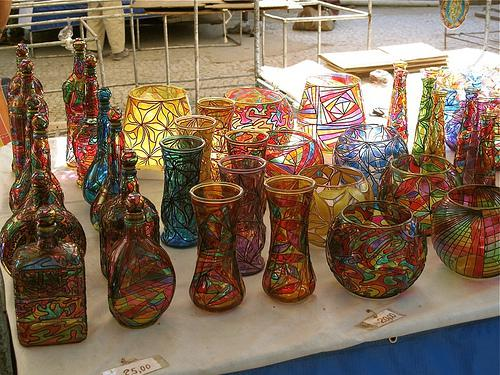Question: what are on display?
Choices:
A. Flowers.
B. Cars.
C. Dresses.
D. Vases.
Answer with the letter. Answer: D Question: what are the vases made of?
Choices:
A. Glass.
B. Porcelin.
C. Plastic.
D. Aluminum.
Answer with the letter. Answer: A Question: why are the vases on display?
Choices:
A. To show the flowers.
B. They are free.
C. For mother's day.
D. They are for sale.
Answer with the letter. Answer: D Question: where are the vases?
Choices:
A. On the table.
B. In the store.
C. On the counter.
D. On the mantel.
Answer with the letter. Answer: A Question: who is in the photo?
Choices:
A. Kobe Bryant.
B. Madonna.
C. Nobody.
D. Hitler.
Answer with the letter. Answer: C 